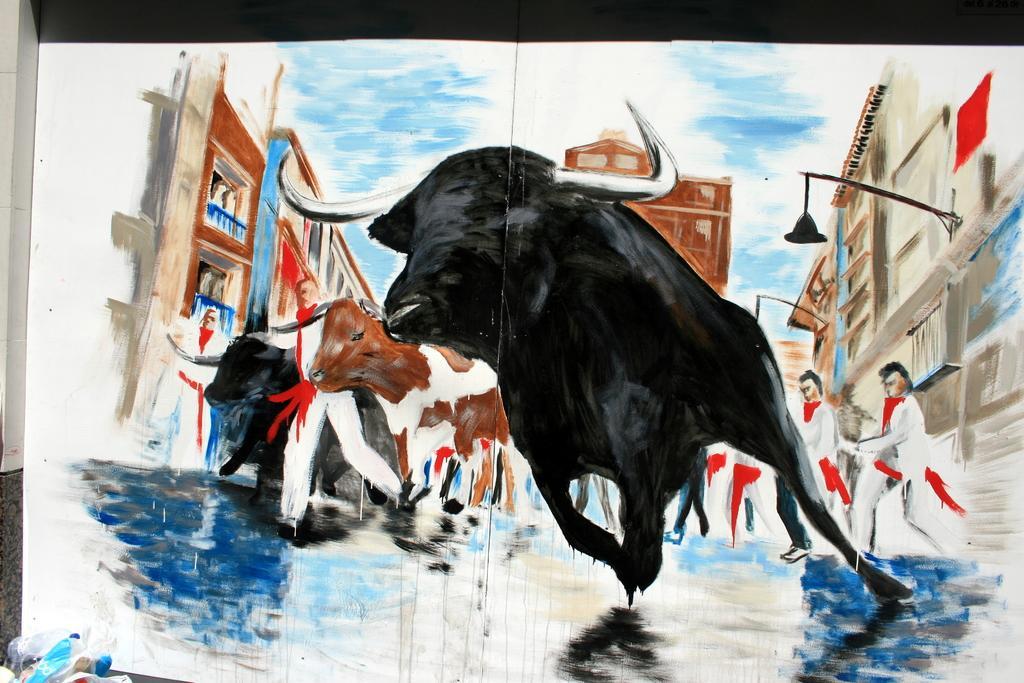Describe this image in one or two sentences. In this image we can see a painting of some animals, persons, buildings and the sky. 